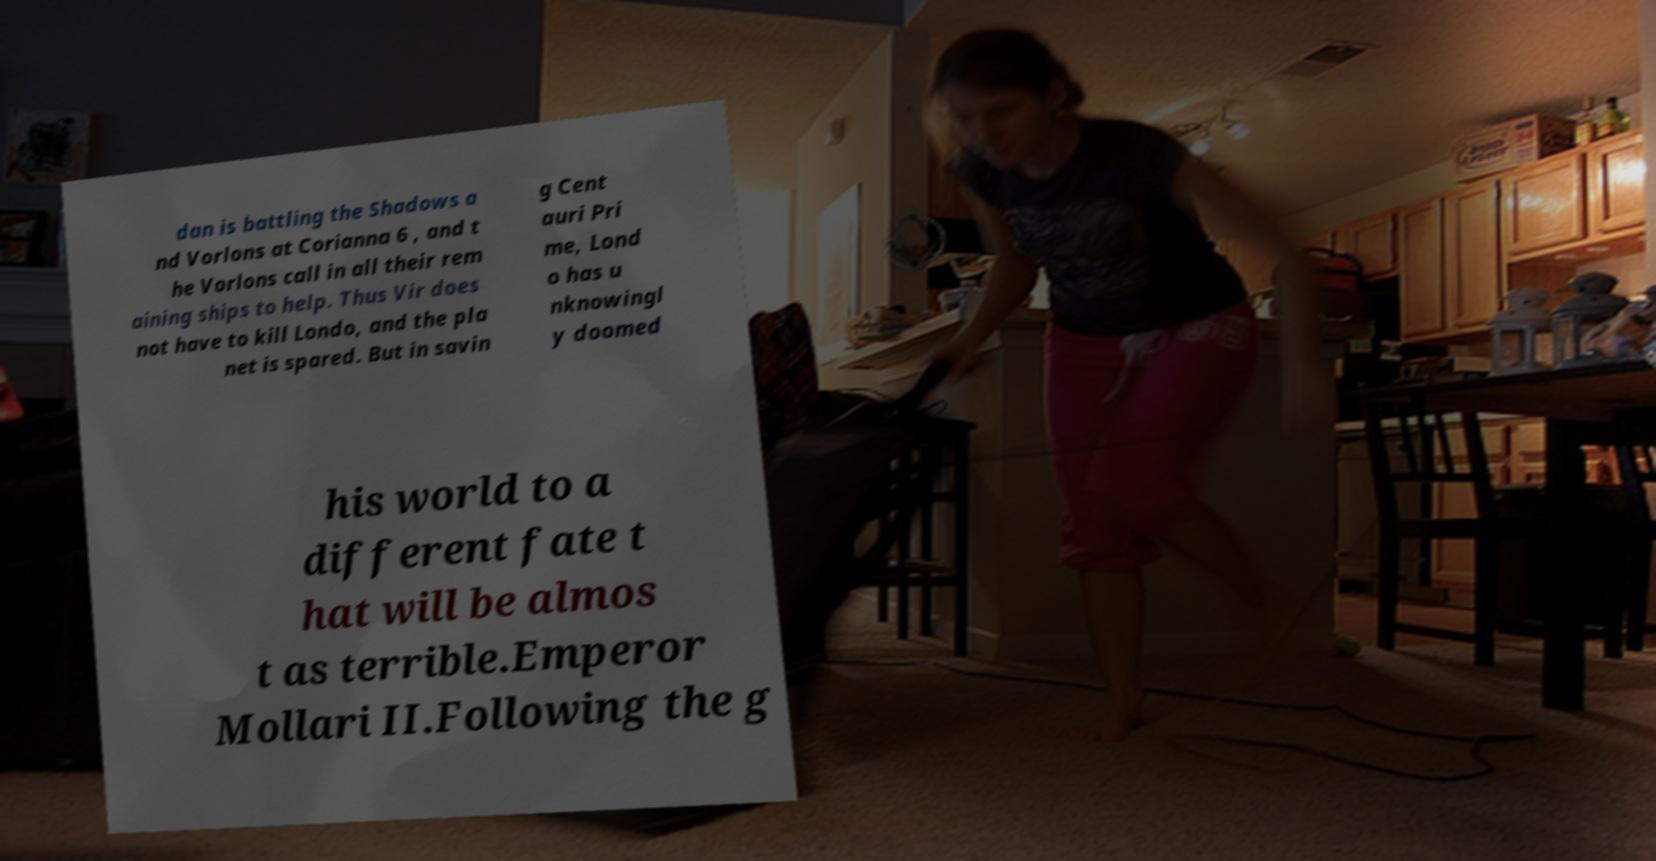Could you extract and type out the text from this image? dan is battling the Shadows a nd Vorlons at Corianna 6 , and t he Vorlons call in all their rem aining ships to help. Thus Vir does not have to kill Londo, and the pla net is spared. But in savin g Cent auri Pri me, Lond o has u nknowingl y doomed his world to a different fate t hat will be almos t as terrible.Emperor Mollari II.Following the g 